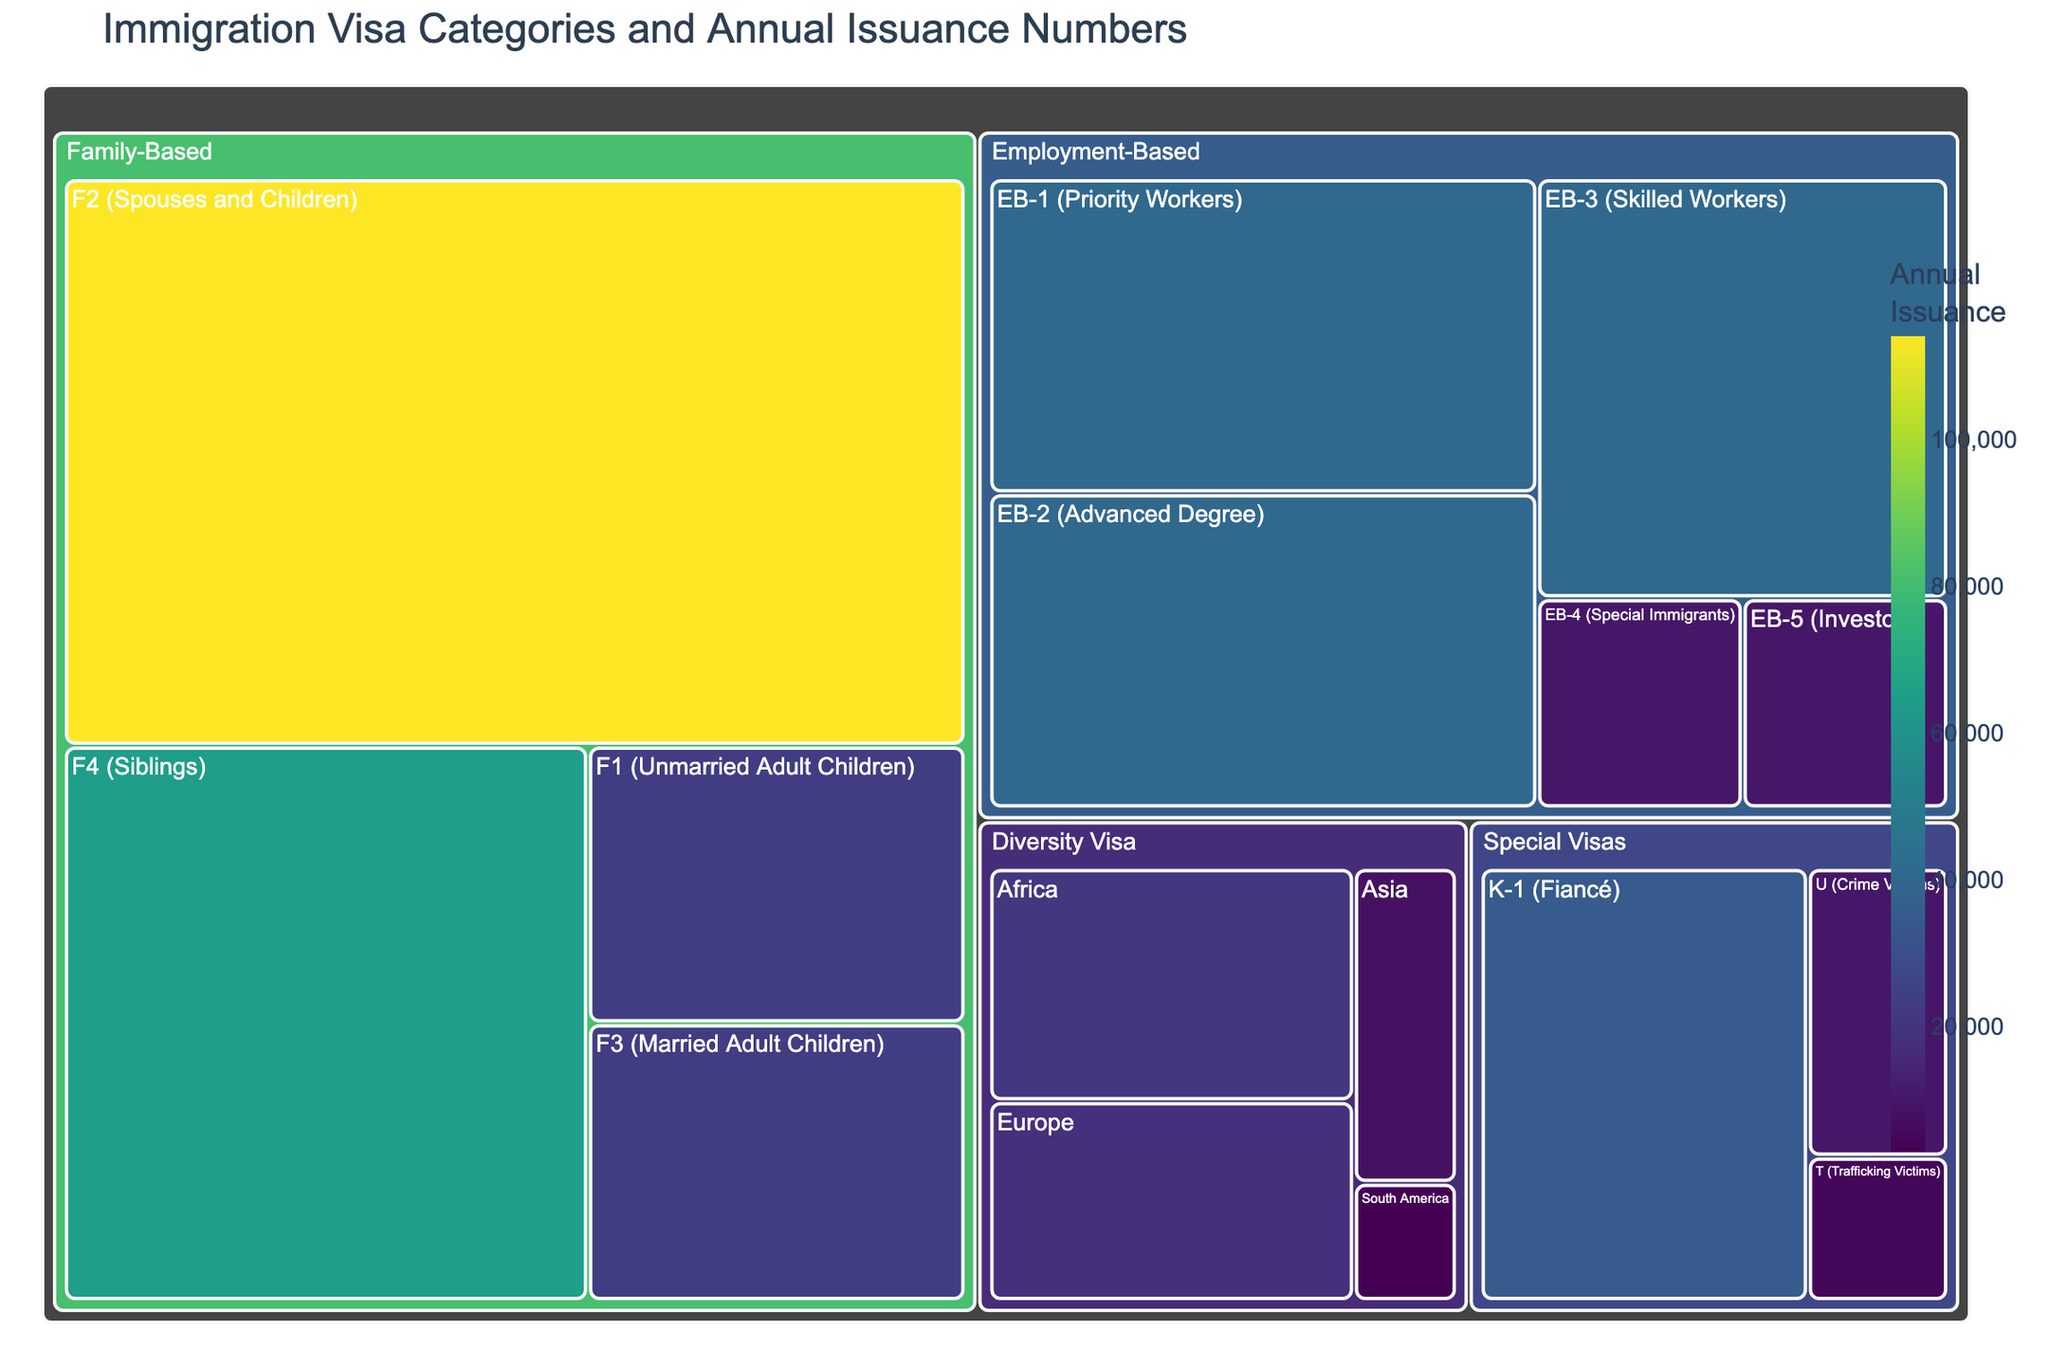Which visa category has the highest annual issuance? The Family-Based category has the highest number of visas issued, which includes subcategories with large values like F2 (Spouses and Children) at 114,200.
Answer: Family-Based What is the total number of visas issued under the Employment-Based category? Summing the values for all Employment-Based subcategories: EB-1 (40,000) + EB-2 (40,000) + EB-3 (40,000) + EB-4 (10,000) + EB-5 (10,000) = 140,000.
Answer: 140,000 Which subcategory in the Diversity Visa category has the lowest annual issuance? In the Diversity Visa category, South America has the lowest issuance number, which is 3,000.
Answer: South America How does the number of visas issued to T (Trafficking Victims) compare to those issued to U (Crime Victims)? The number of visas issued to T (Trafficking Victims) is 5,000, while for U (Crime Victims) it is 10,000. Therefore, U has twice the issuance of T.
Answer: U has twice the issuance of T What are the three largest subcategories by annual issuance numbers? The subcategories with the three highest issuance numbers are: F2 (Spouses and Children) at 114,200, followed by EB-1, EB-2, and EB-3 each at 40,000.
Answer: F2, EB-1, EB-2, and EB-3 How many more visas are issued under F1 (Unmarried Adult Children) compared to the Diversity Visa for Asia? F1 (Unmarried Adult Children) has 23,400 visas, and Diversity Visa for Asia has 8,000 visas. The difference is 23,400 - 8,000 = 15,400.
Answer: 15,400 Within the Special Visas category, which subcategory has the highest number of visas issued? In the Special Visas category, the K-1 (Fiancé) subcategory has the highest number of visas issued, which is 35,000.
Answer: K-1 (Fiancé) What is the combined total of visas issued for all Diversity Visa subcategories? Adding the values for all Diversity Visa subcategories: Africa (21,000) + Europe (18,000) + Asia (8,000) + South America (3,000) = 50,000.
Answer: 50,000 How does the title of the treemap help in understanding the data it represents? The title "Immigration Visa Categories and Annual Issuance Numbers" clearly indicates that the figure shows different categories of visas and the number of visas issued per year for each subcategory, helping viewers to understand what the data represents at a glance.
Answer: It clarifies the data represented Which subcategory in the Family-Based category has the smallest number of issued visas and how does it compare to the largest subcategory in the same category? The smallest subcategory in Family-Based is F1 (Unmarried Adult Children) with 23,400 visas. The largest is F2 (Spouses and Children) with 114,200 visas. Comparing the two, F2 has nearly 4.9 times the number of visas issued as F1.
Answer: F1 has 4.9 times fewer visas compared to F2 